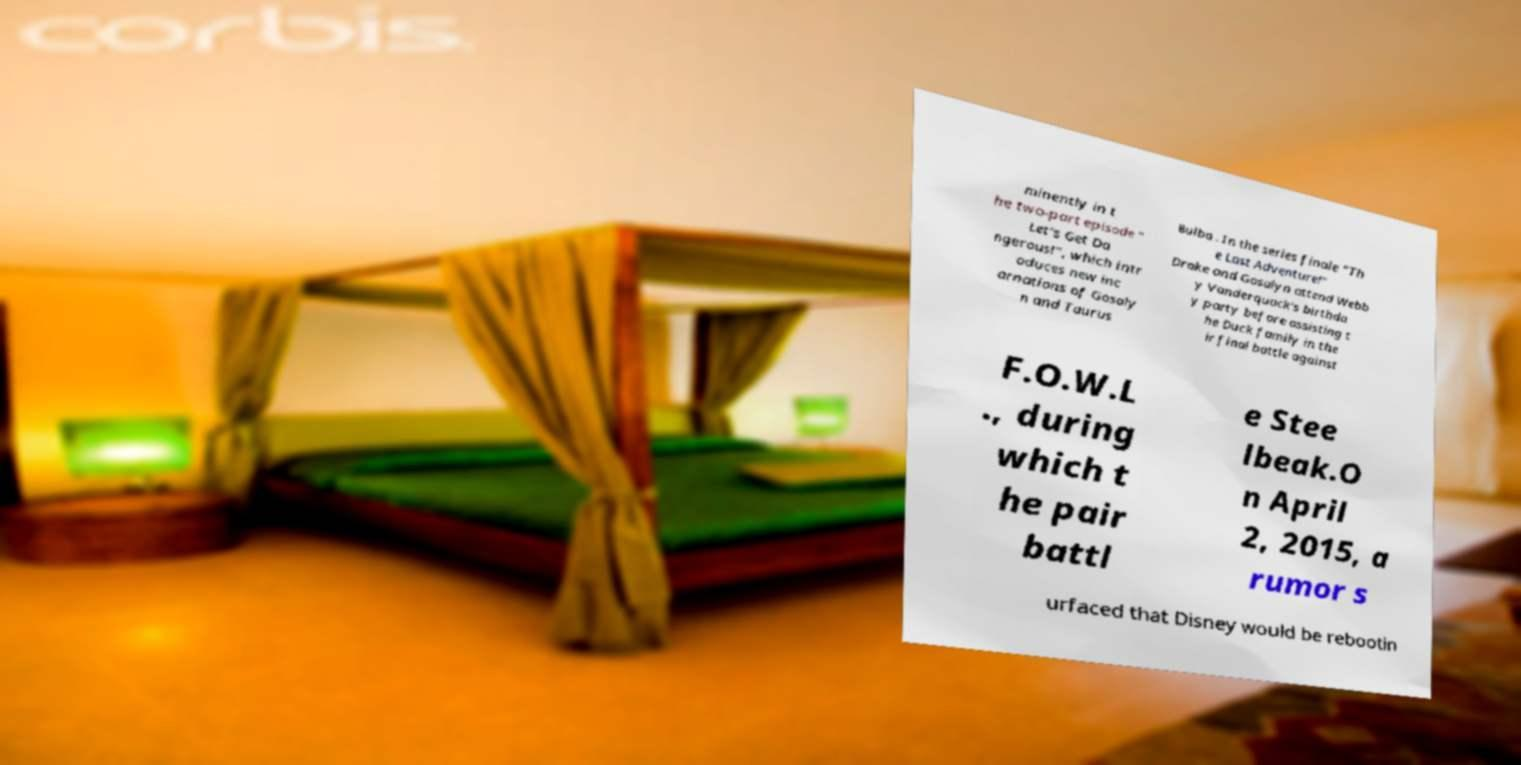Can you read and provide the text displayed in the image?This photo seems to have some interesting text. Can you extract and type it out for me? minently in t he two-part episode " Let's Get Da ngerous!", which intr oduces new inc arnations of Gosaly n and Taurus Bulba . In the series finale "Th e Last Adventure!" Drake and Gosalyn attend Webb y Vanderquack's birthda y party before assisting t he Duck family in the ir final battle against F.O.W.L ., during which t he pair battl e Stee lbeak.O n April 2, 2015, a rumor s urfaced that Disney would be rebootin 